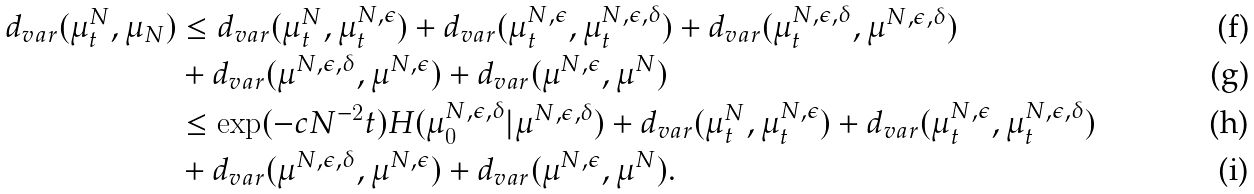Convert formula to latex. <formula><loc_0><loc_0><loc_500><loc_500>d _ { v a r } ( \mu _ { t } ^ { N } , \mu _ { N } ) & \leq d _ { v a r } ( \mu _ { t } ^ { N } , \mu _ { t } ^ { N , \epsilon } ) + d _ { v a r } ( \mu _ { t } ^ { N , \epsilon } , \mu _ { t } ^ { N , \epsilon , \delta } ) + d _ { v a r } ( \mu _ { t } ^ { N , \epsilon , \delta } , \mu ^ { N , \epsilon , \delta } ) \\ & + d _ { v a r } ( \mu ^ { N , \epsilon , \delta } , \mu ^ { N , \epsilon } ) + d _ { v a r } ( \mu ^ { N , \epsilon } , \mu ^ { N } ) \\ & \leq \exp ( - c N ^ { - 2 } t ) H ( \mu _ { 0 } ^ { N , \epsilon , \delta } | \mu ^ { N , \epsilon , \delta } ) + d _ { v a r } ( \mu _ { t } ^ { N } , \mu _ { t } ^ { N , \epsilon } ) + d _ { v a r } ( \mu _ { t } ^ { N , \epsilon } , \mu _ { t } ^ { N , \epsilon , \delta } ) \\ & + d _ { v a r } ( \mu ^ { N , \epsilon , \delta } , \mu ^ { N , \epsilon } ) + d _ { v a r } ( \mu ^ { N , \epsilon } , \mu ^ { N } ) .</formula> 